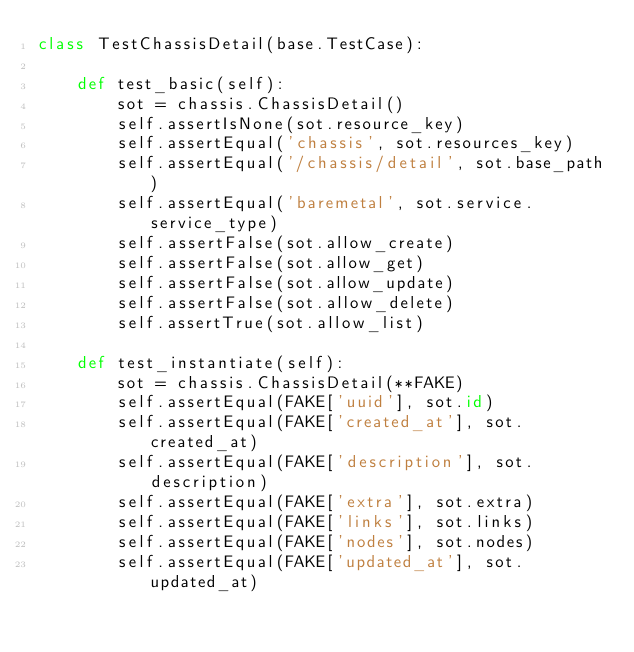<code> <loc_0><loc_0><loc_500><loc_500><_Python_>class TestChassisDetail(base.TestCase):

    def test_basic(self):
        sot = chassis.ChassisDetail()
        self.assertIsNone(sot.resource_key)
        self.assertEqual('chassis', sot.resources_key)
        self.assertEqual('/chassis/detail', sot.base_path)
        self.assertEqual('baremetal', sot.service.service_type)
        self.assertFalse(sot.allow_create)
        self.assertFalse(sot.allow_get)
        self.assertFalse(sot.allow_update)
        self.assertFalse(sot.allow_delete)
        self.assertTrue(sot.allow_list)

    def test_instantiate(self):
        sot = chassis.ChassisDetail(**FAKE)
        self.assertEqual(FAKE['uuid'], sot.id)
        self.assertEqual(FAKE['created_at'], sot.created_at)
        self.assertEqual(FAKE['description'], sot.description)
        self.assertEqual(FAKE['extra'], sot.extra)
        self.assertEqual(FAKE['links'], sot.links)
        self.assertEqual(FAKE['nodes'], sot.nodes)
        self.assertEqual(FAKE['updated_at'], sot.updated_at)
</code> 